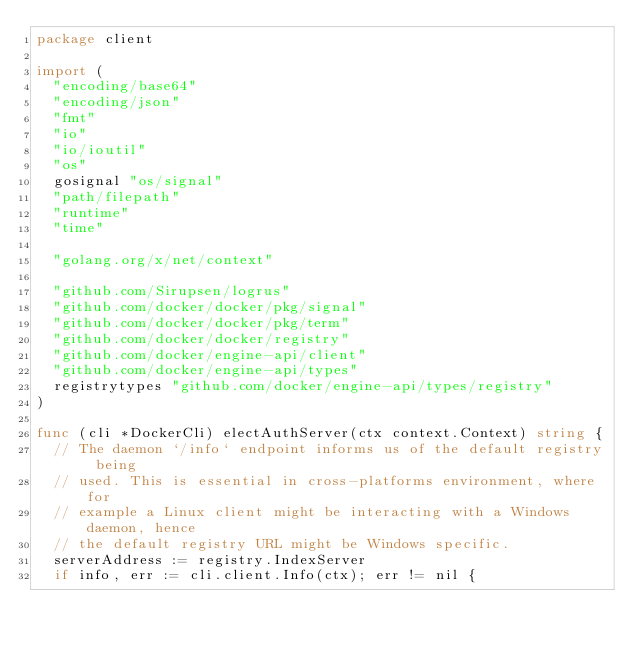Convert code to text. <code><loc_0><loc_0><loc_500><loc_500><_Go_>package client

import (
	"encoding/base64"
	"encoding/json"
	"fmt"
	"io"
	"io/ioutil"
	"os"
	gosignal "os/signal"
	"path/filepath"
	"runtime"
	"time"

	"golang.org/x/net/context"

	"github.com/Sirupsen/logrus"
	"github.com/docker/docker/pkg/signal"
	"github.com/docker/docker/pkg/term"
	"github.com/docker/docker/registry"
	"github.com/docker/engine-api/client"
	"github.com/docker/engine-api/types"
	registrytypes "github.com/docker/engine-api/types/registry"
)

func (cli *DockerCli) electAuthServer(ctx context.Context) string {
	// The daemon `/info` endpoint informs us of the default registry being
	// used. This is essential in cross-platforms environment, where for
	// example a Linux client might be interacting with a Windows daemon, hence
	// the default registry URL might be Windows specific.
	serverAddress := registry.IndexServer
	if info, err := cli.client.Info(ctx); err != nil {</code> 